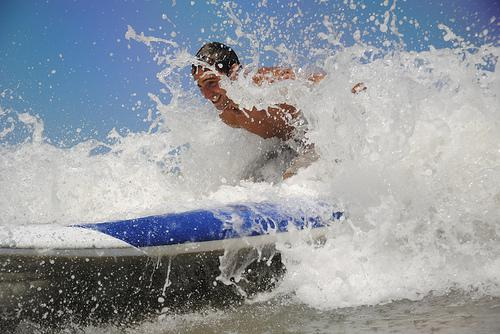Question: what color is the man's hair?
Choices:
A. Black.
B. Blonde.
C. Red.
D. Gray.
Answer with the letter. Answer: A Question: what is the man on?
Choices:
A. Surf board.
B. His motorcycle.
C. A horse.
D. Skateboard.
Answer with the letter. Answer: A Question: what is the man doing?
Choices:
A. Singing.
B. Painting.
C. Surfing.
D. Sleeping.
Answer with the letter. Answer: C Question: what type of water can be seen?
Choices:
A. Crystal blue.
B. Dark and murky.
C. Pond water.
D. A wave.
Answer with the letter. Answer: D 